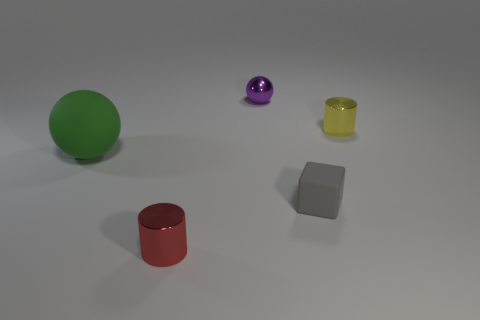Is there anything else that is the same size as the green rubber ball?
Provide a succinct answer. No. There is a red cylinder that is made of the same material as the small purple object; what is its size?
Offer a very short reply. Small. There is a object that is both on the left side of the purple sphere and to the right of the green thing; what is its color?
Offer a very short reply. Red. What number of rubber cubes have the same size as the red cylinder?
Offer a terse response. 1. What size is the thing that is behind the red metal object and on the left side of the purple ball?
Give a very brief answer. Large. What number of shiny spheres are to the left of the metal object behind the cylinder behind the small red metallic cylinder?
Provide a succinct answer. 0. What is the color of the sphere that is the same size as the gray rubber object?
Provide a succinct answer. Purple. What shape is the rubber object in front of the big green thing behind the cylinder in front of the green sphere?
Provide a short and direct response. Cube. There is a small metal object in front of the green ball; how many small shiny cylinders are right of it?
Your response must be concise. 1. Do the tiny metallic thing in front of the large green ball and the shiny thing that is on the right side of the purple ball have the same shape?
Offer a very short reply. Yes. 